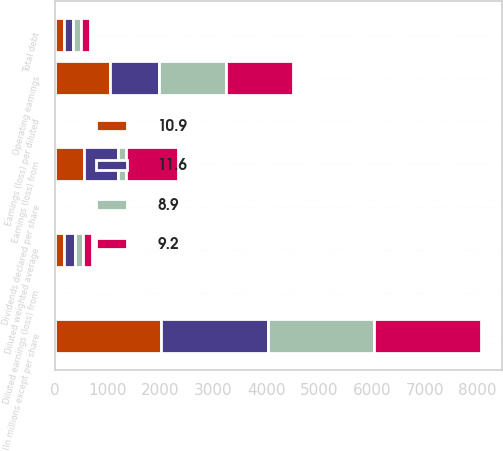Convert chart. <chart><loc_0><loc_0><loc_500><loc_500><stacked_bar_chart><ecel><fcel>(In millions except per share<fcel>Operating earnings<fcel>Earnings (loss) from<fcel>Diluted earnings (loss) from<fcel>Earnings (loss) per diluted<fcel>Diluted weighted average<fcel>Dividends declared per share<fcel>Total debt<nl><fcel>9.2<fcel>2018<fcel>1255<fcel>966<fcel>5.62<fcel>5.62<fcel>172<fcel>2.13<fcel>167.45<nl><fcel>8.9<fcel>2017<fcel>1284<fcel>155<fcel>0.95<fcel>0.95<fcel>162.9<fcel>1.93<fcel>167.45<nl><fcel>10.9<fcel>2016<fcel>1048<fcel>560<fcel>3.24<fcel>3.24<fcel>173.1<fcel>1.7<fcel>167.45<nl><fcel>11.6<fcel>2015<fcel>916<fcel>640<fcel>3.17<fcel>3.02<fcel>201.8<fcel>1.43<fcel>167.45<nl></chart> 